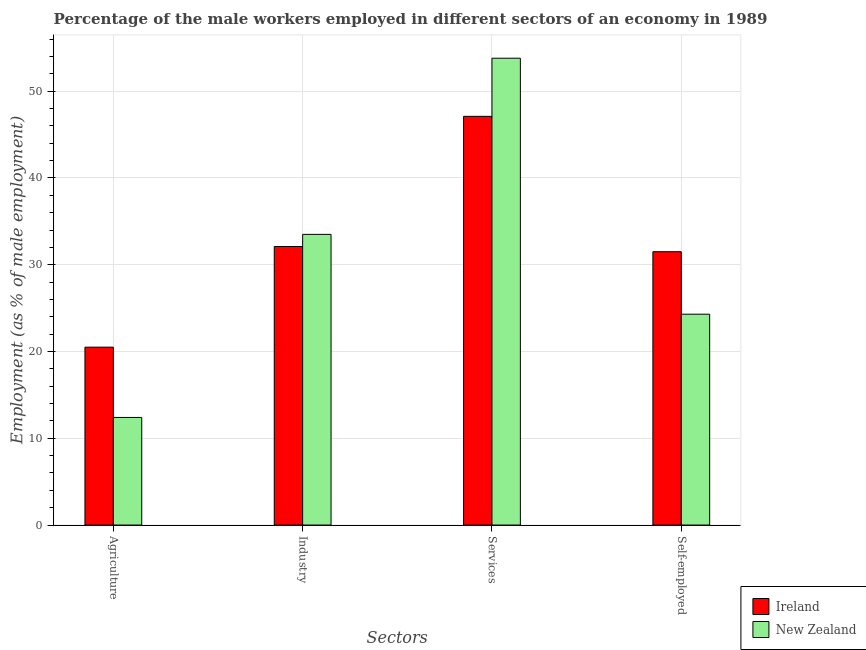How many groups of bars are there?
Give a very brief answer. 4. Are the number of bars per tick equal to the number of legend labels?
Provide a short and direct response. Yes. How many bars are there on the 4th tick from the left?
Keep it short and to the point. 2. How many bars are there on the 2nd tick from the right?
Ensure brevity in your answer.  2. What is the label of the 3rd group of bars from the left?
Your answer should be compact. Services. Across all countries, what is the maximum percentage of male workers in industry?
Offer a very short reply. 33.5. Across all countries, what is the minimum percentage of male workers in services?
Keep it short and to the point. 47.1. In which country was the percentage of male workers in industry maximum?
Provide a short and direct response. New Zealand. In which country was the percentage of male workers in industry minimum?
Provide a succinct answer. Ireland. What is the total percentage of male workers in agriculture in the graph?
Your answer should be compact. 32.9. What is the difference between the percentage of male workers in services in Ireland and that in New Zealand?
Provide a succinct answer. -6.7. What is the difference between the percentage of self employed male workers in Ireland and the percentage of male workers in industry in New Zealand?
Offer a very short reply. -2. What is the average percentage of male workers in industry per country?
Keep it short and to the point. 32.8. What is the difference between the percentage of self employed male workers and percentage of male workers in services in New Zealand?
Keep it short and to the point. -29.5. What is the ratio of the percentage of male workers in industry in Ireland to that in New Zealand?
Offer a very short reply. 0.96. Is the percentage of self employed male workers in New Zealand less than that in Ireland?
Keep it short and to the point. Yes. Is the difference between the percentage of male workers in agriculture in New Zealand and Ireland greater than the difference between the percentage of male workers in services in New Zealand and Ireland?
Offer a very short reply. No. What is the difference between the highest and the second highest percentage of male workers in agriculture?
Your answer should be very brief. 8.1. What is the difference between the highest and the lowest percentage of self employed male workers?
Ensure brevity in your answer.  7.2. In how many countries, is the percentage of male workers in agriculture greater than the average percentage of male workers in agriculture taken over all countries?
Provide a short and direct response. 1. What does the 1st bar from the left in Agriculture represents?
Offer a very short reply. Ireland. What does the 1st bar from the right in Industry represents?
Provide a short and direct response. New Zealand. Is it the case that in every country, the sum of the percentage of male workers in agriculture and percentage of male workers in industry is greater than the percentage of male workers in services?
Your answer should be compact. No. How many bars are there?
Keep it short and to the point. 8. Are all the bars in the graph horizontal?
Provide a short and direct response. No. How many countries are there in the graph?
Provide a short and direct response. 2. What is the difference between two consecutive major ticks on the Y-axis?
Keep it short and to the point. 10. Are the values on the major ticks of Y-axis written in scientific E-notation?
Make the answer very short. No. Does the graph contain any zero values?
Keep it short and to the point. No. How are the legend labels stacked?
Keep it short and to the point. Vertical. What is the title of the graph?
Provide a short and direct response. Percentage of the male workers employed in different sectors of an economy in 1989. What is the label or title of the X-axis?
Your answer should be compact. Sectors. What is the label or title of the Y-axis?
Keep it short and to the point. Employment (as % of male employment). What is the Employment (as % of male employment) of New Zealand in Agriculture?
Provide a succinct answer. 12.4. What is the Employment (as % of male employment) of Ireland in Industry?
Your response must be concise. 32.1. What is the Employment (as % of male employment) in New Zealand in Industry?
Your response must be concise. 33.5. What is the Employment (as % of male employment) of Ireland in Services?
Provide a short and direct response. 47.1. What is the Employment (as % of male employment) in New Zealand in Services?
Make the answer very short. 53.8. What is the Employment (as % of male employment) of Ireland in Self-employed?
Give a very brief answer. 31.5. What is the Employment (as % of male employment) of New Zealand in Self-employed?
Make the answer very short. 24.3. Across all Sectors, what is the maximum Employment (as % of male employment) in Ireland?
Your answer should be very brief. 47.1. Across all Sectors, what is the maximum Employment (as % of male employment) of New Zealand?
Offer a very short reply. 53.8. Across all Sectors, what is the minimum Employment (as % of male employment) of New Zealand?
Provide a short and direct response. 12.4. What is the total Employment (as % of male employment) in Ireland in the graph?
Provide a succinct answer. 131.2. What is the total Employment (as % of male employment) in New Zealand in the graph?
Make the answer very short. 124. What is the difference between the Employment (as % of male employment) of Ireland in Agriculture and that in Industry?
Make the answer very short. -11.6. What is the difference between the Employment (as % of male employment) in New Zealand in Agriculture and that in Industry?
Ensure brevity in your answer.  -21.1. What is the difference between the Employment (as % of male employment) in Ireland in Agriculture and that in Services?
Keep it short and to the point. -26.6. What is the difference between the Employment (as % of male employment) of New Zealand in Agriculture and that in Services?
Offer a terse response. -41.4. What is the difference between the Employment (as % of male employment) of New Zealand in Agriculture and that in Self-employed?
Offer a terse response. -11.9. What is the difference between the Employment (as % of male employment) in New Zealand in Industry and that in Services?
Offer a very short reply. -20.3. What is the difference between the Employment (as % of male employment) of Ireland in Industry and that in Self-employed?
Provide a short and direct response. 0.6. What is the difference between the Employment (as % of male employment) in Ireland in Services and that in Self-employed?
Keep it short and to the point. 15.6. What is the difference between the Employment (as % of male employment) in New Zealand in Services and that in Self-employed?
Provide a succinct answer. 29.5. What is the difference between the Employment (as % of male employment) in Ireland in Agriculture and the Employment (as % of male employment) in New Zealand in Services?
Provide a short and direct response. -33.3. What is the difference between the Employment (as % of male employment) in Ireland in Industry and the Employment (as % of male employment) in New Zealand in Services?
Give a very brief answer. -21.7. What is the difference between the Employment (as % of male employment) of Ireland in Industry and the Employment (as % of male employment) of New Zealand in Self-employed?
Your answer should be very brief. 7.8. What is the difference between the Employment (as % of male employment) of Ireland in Services and the Employment (as % of male employment) of New Zealand in Self-employed?
Give a very brief answer. 22.8. What is the average Employment (as % of male employment) in Ireland per Sectors?
Ensure brevity in your answer.  32.8. What is the difference between the Employment (as % of male employment) of Ireland and Employment (as % of male employment) of New Zealand in Industry?
Offer a very short reply. -1.4. What is the difference between the Employment (as % of male employment) of Ireland and Employment (as % of male employment) of New Zealand in Services?
Your answer should be compact. -6.7. What is the ratio of the Employment (as % of male employment) of Ireland in Agriculture to that in Industry?
Give a very brief answer. 0.64. What is the ratio of the Employment (as % of male employment) in New Zealand in Agriculture to that in Industry?
Provide a succinct answer. 0.37. What is the ratio of the Employment (as % of male employment) of Ireland in Agriculture to that in Services?
Offer a terse response. 0.44. What is the ratio of the Employment (as % of male employment) of New Zealand in Agriculture to that in Services?
Make the answer very short. 0.23. What is the ratio of the Employment (as % of male employment) in Ireland in Agriculture to that in Self-employed?
Give a very brief answer. 0.65. What is the ratio of the Employment (as % of male employment) in New Zealand in Agriculture to that in Self-employed?
Provide a short and direct response. 0.51. What is the ratio of the Employment (as % of male employment) in Ireland in Industry to that in Services?
Your response must be concise. 0.68. What is the ratio of the Employment (as % of male employment) of New Zealand in Industry to that in Services?
Ensure brevity in your answer.  0.62. What is the ratio of the Employment (as % of male employment) in Ireland in Industry to that in Self-employed?
Offer a very short reply. 1.02. What is the ratio of the Employment (as % of male employment) in New Zealand in Industry to that in Self-employed?
Your answer should be compact. 1.38. What is the ratio of the Employment (as % of male employment) in Ireland in Services to that in Self-employed?
Give a very brief answer. 1.5. What is the ratio of the Employment (as % of male employment) in New Zealand in Services to that in Self-employed?
Your answer should be very brief. 2.21. What is the difference between the highest and the second highest Employment (as % of male employment) in Ireland?
Provide a short and direct response. 15. What is the difference between the highest and the second highest Employment (as % of male employment) in New Zealand?
Your response must be concise. 20.3. What is the difference between the highest and the lowest Employment (as % of male employment) in Ireland?
Keep it short and to the point. 26.6. What is the difference between the highest and the lowest Employment (as % of male employment) in New Zealand?
Offer a terse response. 41.4. 